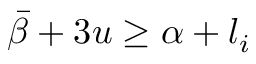Convert formula to latex. <formula><loc_0><loc_0><loc_500><loc_500>\bar { \beta } + 3 u \geq \alpha + l _ { i }</formula> 